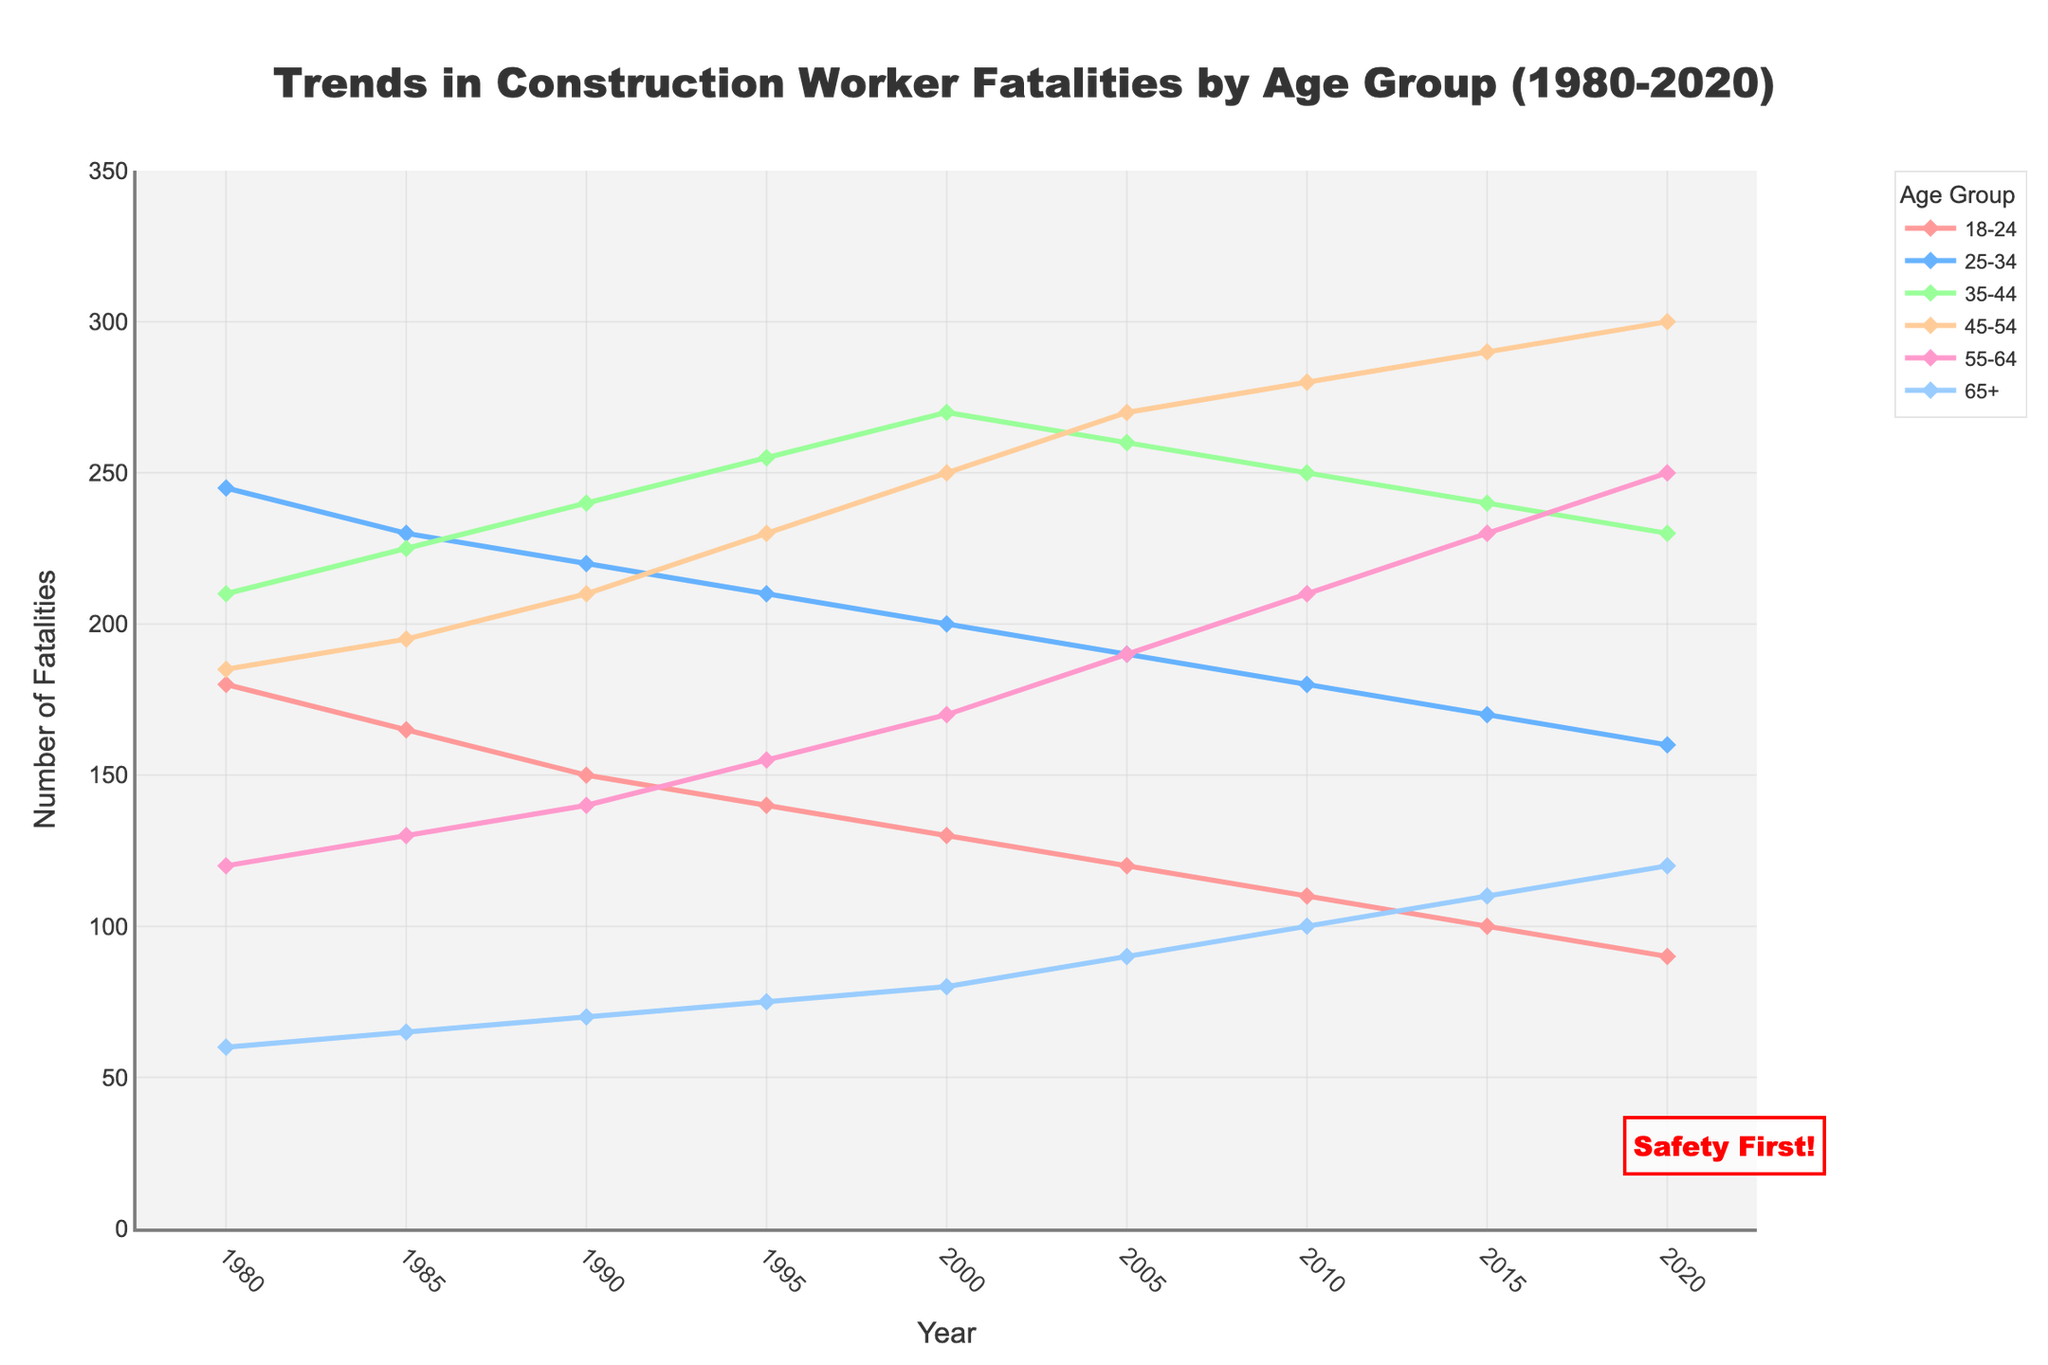Which age group showed a continuous increase in fatalities from 1980 to 2020? We need to look for the age group line that increases steadily without decreasing at any year. The 55-64 age group's line increases continuously from 120 in 1980 to 250 in 2020.
Answer: 55-64 Which age group had the highest number of fatalities in 2020? By examining the lines' endpoints in 2020, we see that the 45-54 age group ends at the highest point, with 300 fatalities.
Answer: 45-54 Was there any year where all age groups had lower fatalities compared to the succeeding year? Compare fatalities year by year. In 1995, all age groups have lower fatalities than in 2000.
Answer: 1995 Which two age groups had the closest number of fatalities in 1980? Compare y-values for each group in 1980. The 18-24 age group had 180 fatalities, while the 45-54 age group had 185, the smallest difference (5).
Answer: 18-24 and 45-54 How many age groups saw their fatalities decrease from 1980 to 2020? Examine the trends for each age group from 1980 to 2020. The 18-24, 25-34, and 35-44 age groups saw a decrease.
Answer: 3 In what year did the 35-44 age group first exceed 250 fatalities? Check the 35-44 line for the first data point where the y-value exceeds 250. In 1995, the fatalities were 255.
Answer: 1995 Which age group's fatalities remained under 100 until 1985? Identify which age group's fatalities were below 100 in both 1980 and 1985. The 65+ group had fatalities of 60 in 1980 and 65 in 1985.
Answer: 65+ During which period did the 45-54 age group see the highest rate of increase in fatalities? Find the period where the slope of the 45-54 age group's line is the steepest. From 2000 to 2005, fatalities increased from 250 to 270.
Answer: 2000-2005 